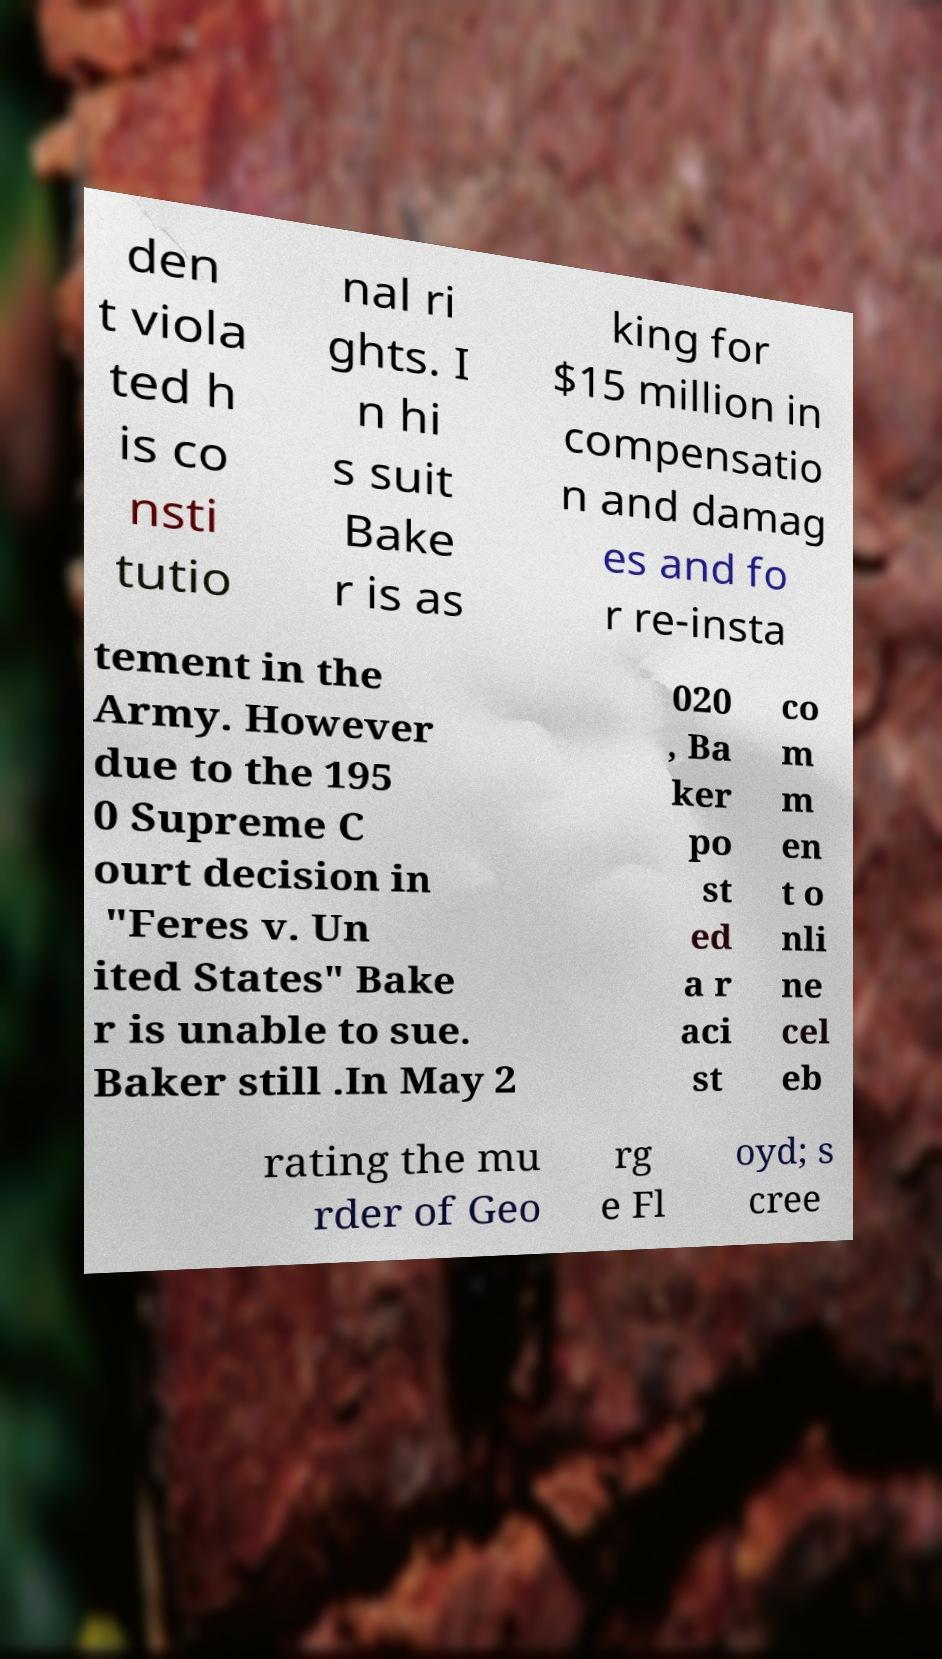Can you accurately transcribe the text from the provided image for me? den t viola ted h is co nsti tutio nal ri ghts. I n hi s suit Bake r is as king for $15 million in compensatio n and damag es and fo r re-insta tement in the Army. However due to the 195 0 Supreme C ourt decision in "Feres v. Un ited States" Bake r is unable to sue. Baker still .In May 2 020 , Ba ker po st ed a r aci st co m m en t o nli ne cel eb rating the mu rder of Geo rg e Fl oyd; s cree 